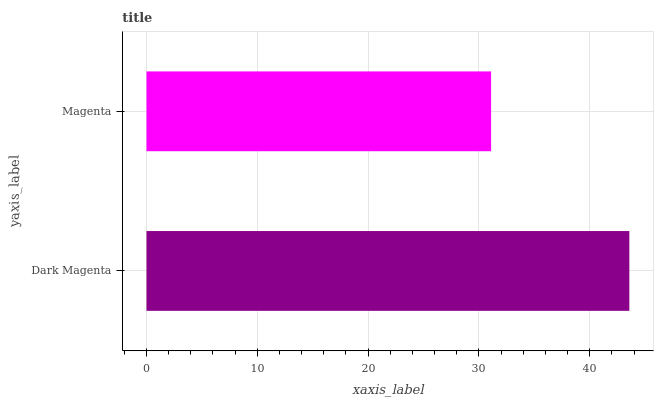Is Magenta the minimum?
Answer yes or no. Yes. Is Dark Magenta the maximum?
Answer yes or no. Yes. Is Magenta the maximum?
Answer yes or no. No. Is Dark Magenta greater than Magenta?
Answer yes or no. Yes. Is Magenta less than Dark Magenta?
Answer yes or no. Yes. Is Magenta greater than Dark Magenta?
Answer yes or no. No. Is Dark Magenta less than Magenta?
Answer yes or no. No. Is Dark Magenta the high median?
Answer yes or no. Yes. Is Magenta the low median?
Answer yes or no. Yes. Is Magenta the high median?
Answer yes or no. No. Is Dark Magenta the low median?
Answer yes or no. No. 